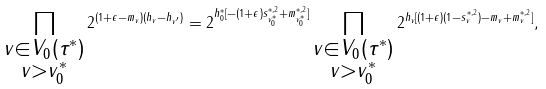Convert formula to latex. <formula><loc_0><loc_0><loc_500><loc_500>\prod _ { \substack { v \in V _ { 0 } ( \tau ^ { * } ) \\ v > v _ { 0 } ^ { * } } } 2 ^ { ( 1 + \epsilon - m _ { v } ) ( h _ { v } - h _ { v ^ { \prime } } ) } = 2 ^ { h ^ { * } _ { 0 } [ - ( 1 + \epsilon ) s ^ { * , 2 } _ { v _ { 0 } ^ { * } } + m ^ { * , 2 } _ { v _ { 0 } ^ { * } } ] } \prod _ { \substack { v \in V _ { 0 } ( \tau ^ { * } ) \\ v > v _ { 0 } ^ { * } } } 2 ^ { h _ { v } [ ( 1 + \epsilon ) ( 1 - s ^ { * , 2 } _ { v } ) - m _ { v } + m ^ { * , 2 } _ { v } ] } ,</formula> 